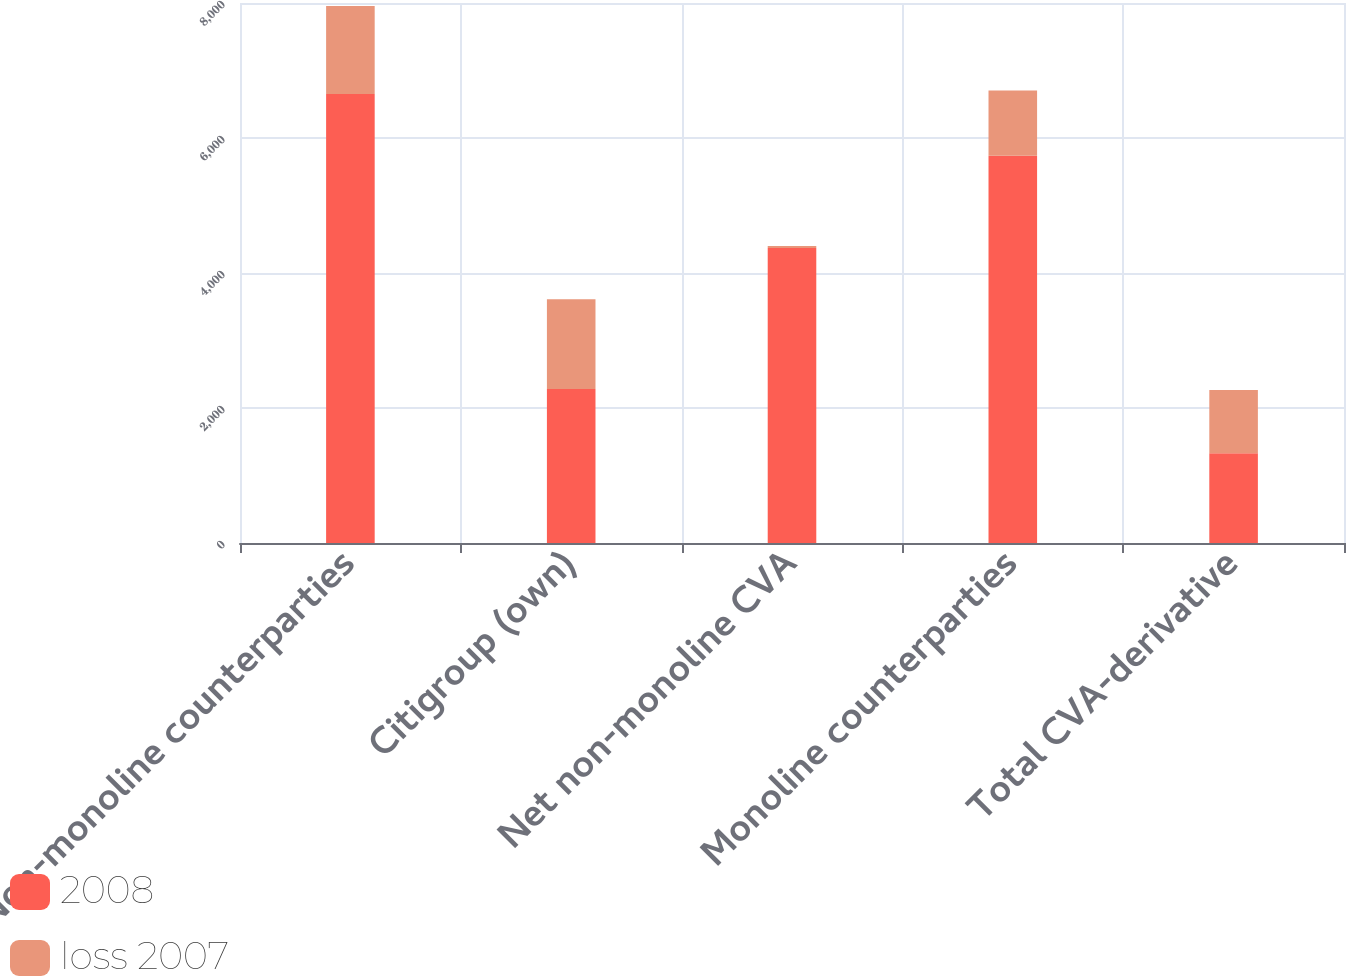<chart> <loc_0><loc_0><loc_500><loc_500><stacked_bar_chart><ecel><fcel>Non-monoline counterparties<fcel>Citigroup (own)<fcel>Net non-monoline CVA<fcel>Monoline counterparties<fcel>Total CVA-derivative<nl><fcel>2008<fcel>6653<fcel>2282<fcel>4371<fcel>5736<fcel>1329<nl><fcel>loss 2007<fcel>1301<fcel>1329<fcel>28<fcel>967<fcel>939<nl></chart> 